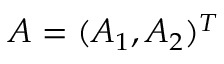Convert formula to latex. <formula><loc_0><loc_0><loc_500><loc_500>A = ( A _ { 1 } , A _ { 2 } ) ^ { T }</formula> 